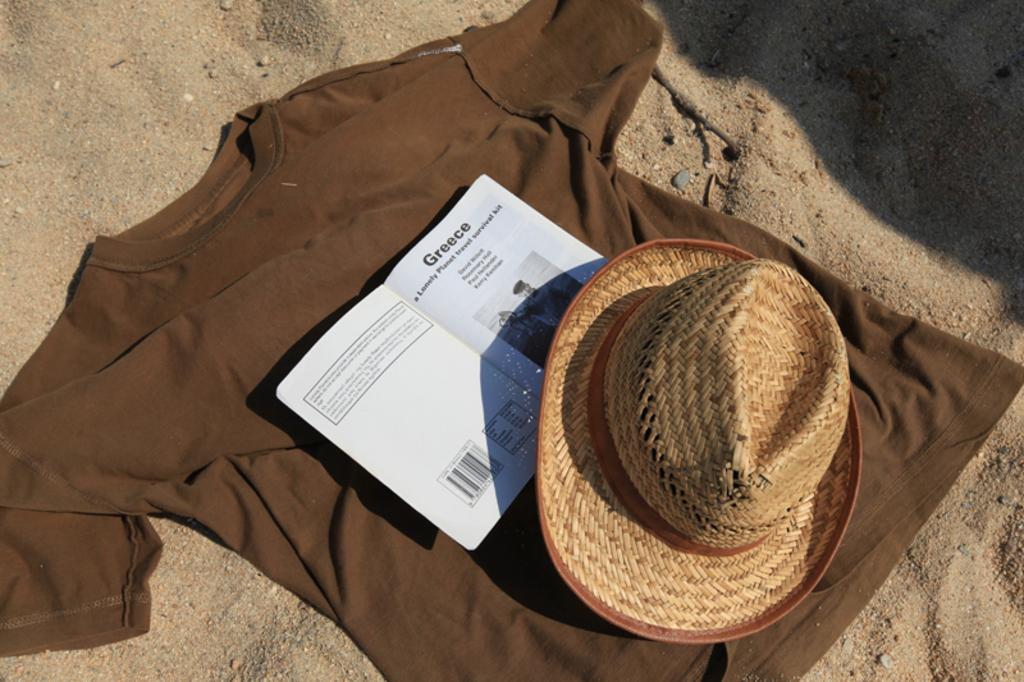What type of clothing item is in the image? There is a t-shirt in the image. What is placed on the t-shirt? There is a book on the t-shirt. What type of headwear is visible in the image? There is a hat in the image. What type of terrain can be seen in the background of the image? There is sand visible in the background of the image. What type of songs can be heard playing in the background of the image? There is no indication of any songs playing in the background of the image. 